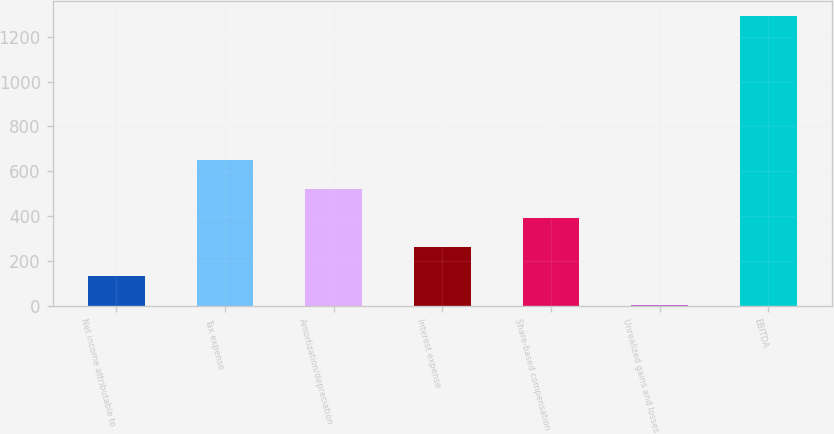Convert chart to OTSL. <chart><loc_0><loc_0><loc_500><loc_500><bar_chart><fcel>Net income attributable to<fcel>Tax expense<fcel>Amortization/depreciation<fcel>Interest expense<fcel>Share-based compensation<fcel>Unrealized gains and losses<fcel>EBITDA<nl><fcel>132.59<fcel>648.55<fcel>519.56<fcel>261.58<fcel>390.57<fcel>3.6<fcel>1293.5<nl></chart> 